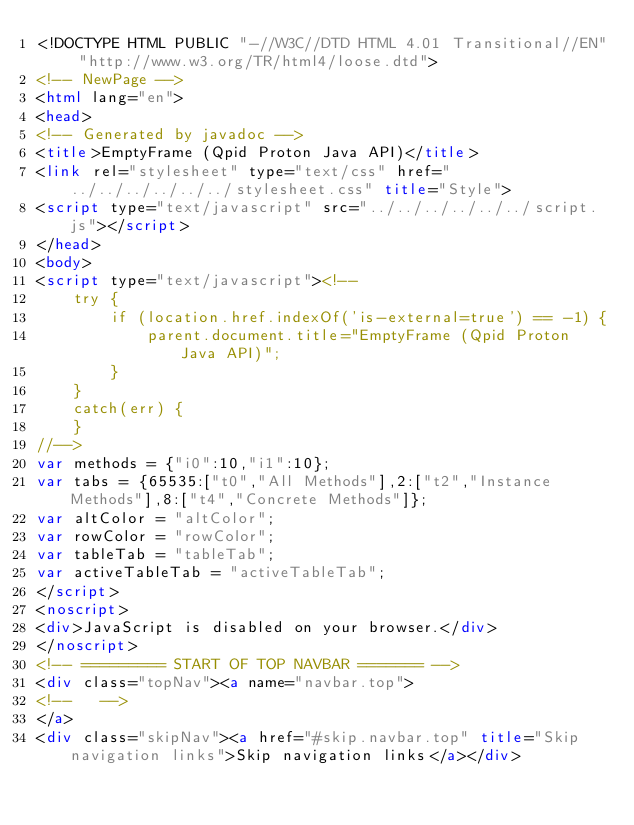<code> <loc_0><loc_0><loc_500><loc_500><_HTML_><!DOCTYPE HTML PUBLIC "-//W3C//DTD HTML 4.01 Transitional//EN" "http://www.w3.org/TR/html4/loose.dtd">
<!-- NewPage -->
<html lang="en">
<head>
<!-- Generated by javadoc -->
<title>EmptyFrame (Qpid Proton Java API)</title>
<link rel="stylesheet" type="text/css" href="../../../../../../stylesheet.css" title="Style">
<script type="text/javascript" src="../../../../../../script.js"></script>
</head>
<body>
<script type="text/javascript"><!--
    try {
        if (location.href.indexOf('is-external=true') == -1) {
            parent.document.title="EmptyFrame (Qpid Proton Java API)";
        }
    }
    catch(err) {
    }
//-->
var methods = {"i0":10,"i1":10};
var tabs = {65535:["t0","All Methods"],2:["t2","Instance Methods"],8:["t4","Concrete Methods"]};
var altColor = "altColor";
var rowColor = "rowColor";
var tableTab = "tableTab";
var activeTableTab = "activeTableTab";
</script>
<noscript>
<div>JavaScript is disabled on your browser.</div>
</noscript>
<!-- ========= START OF TOP NAVBAR ======= -->
<div class="topNav"><a name="navbar.top">
<!--   -->
</a>
<div class="skipNav"><a href="#skip.navbar.top" title="Skip navigation links">Skip navigation links</a></div></code> 